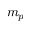<formula> <loc_0><loc_0><loc_500><loc_500>m _ { p }</formula> 